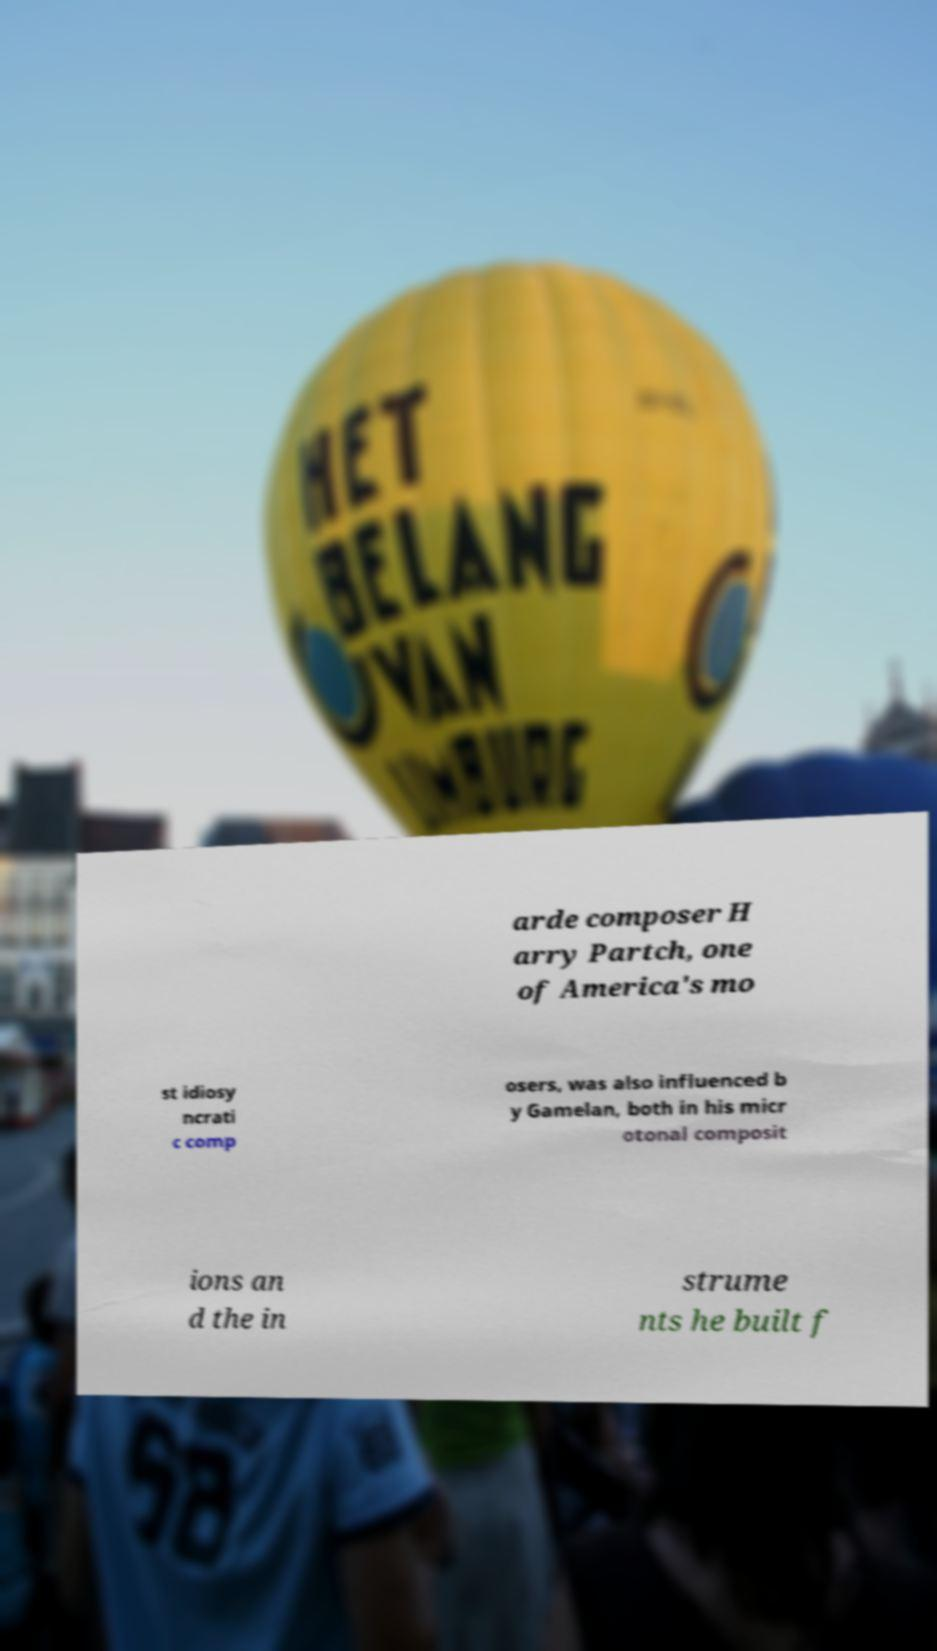There's text embedded in this image that I need extracted. Can you transcribe it verbatim? arde composer H arry Partch, one of America's mo st idiosy ncrati c comp osers, was also influenced b y Gamelan, both in his micr otonal composit ions an d the in strume nts he built f 